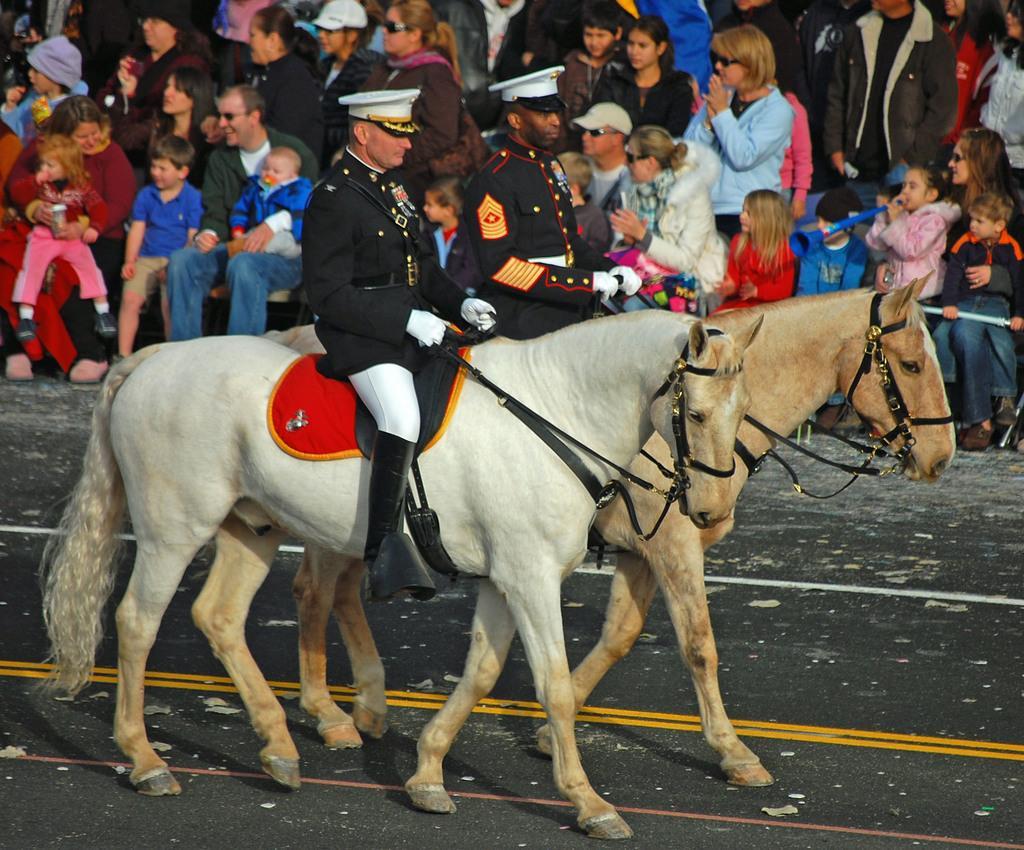Could you give a brief overview of what you see in this image? There are two people wearing white cap and riding on two different horses and there are audience in the background. 